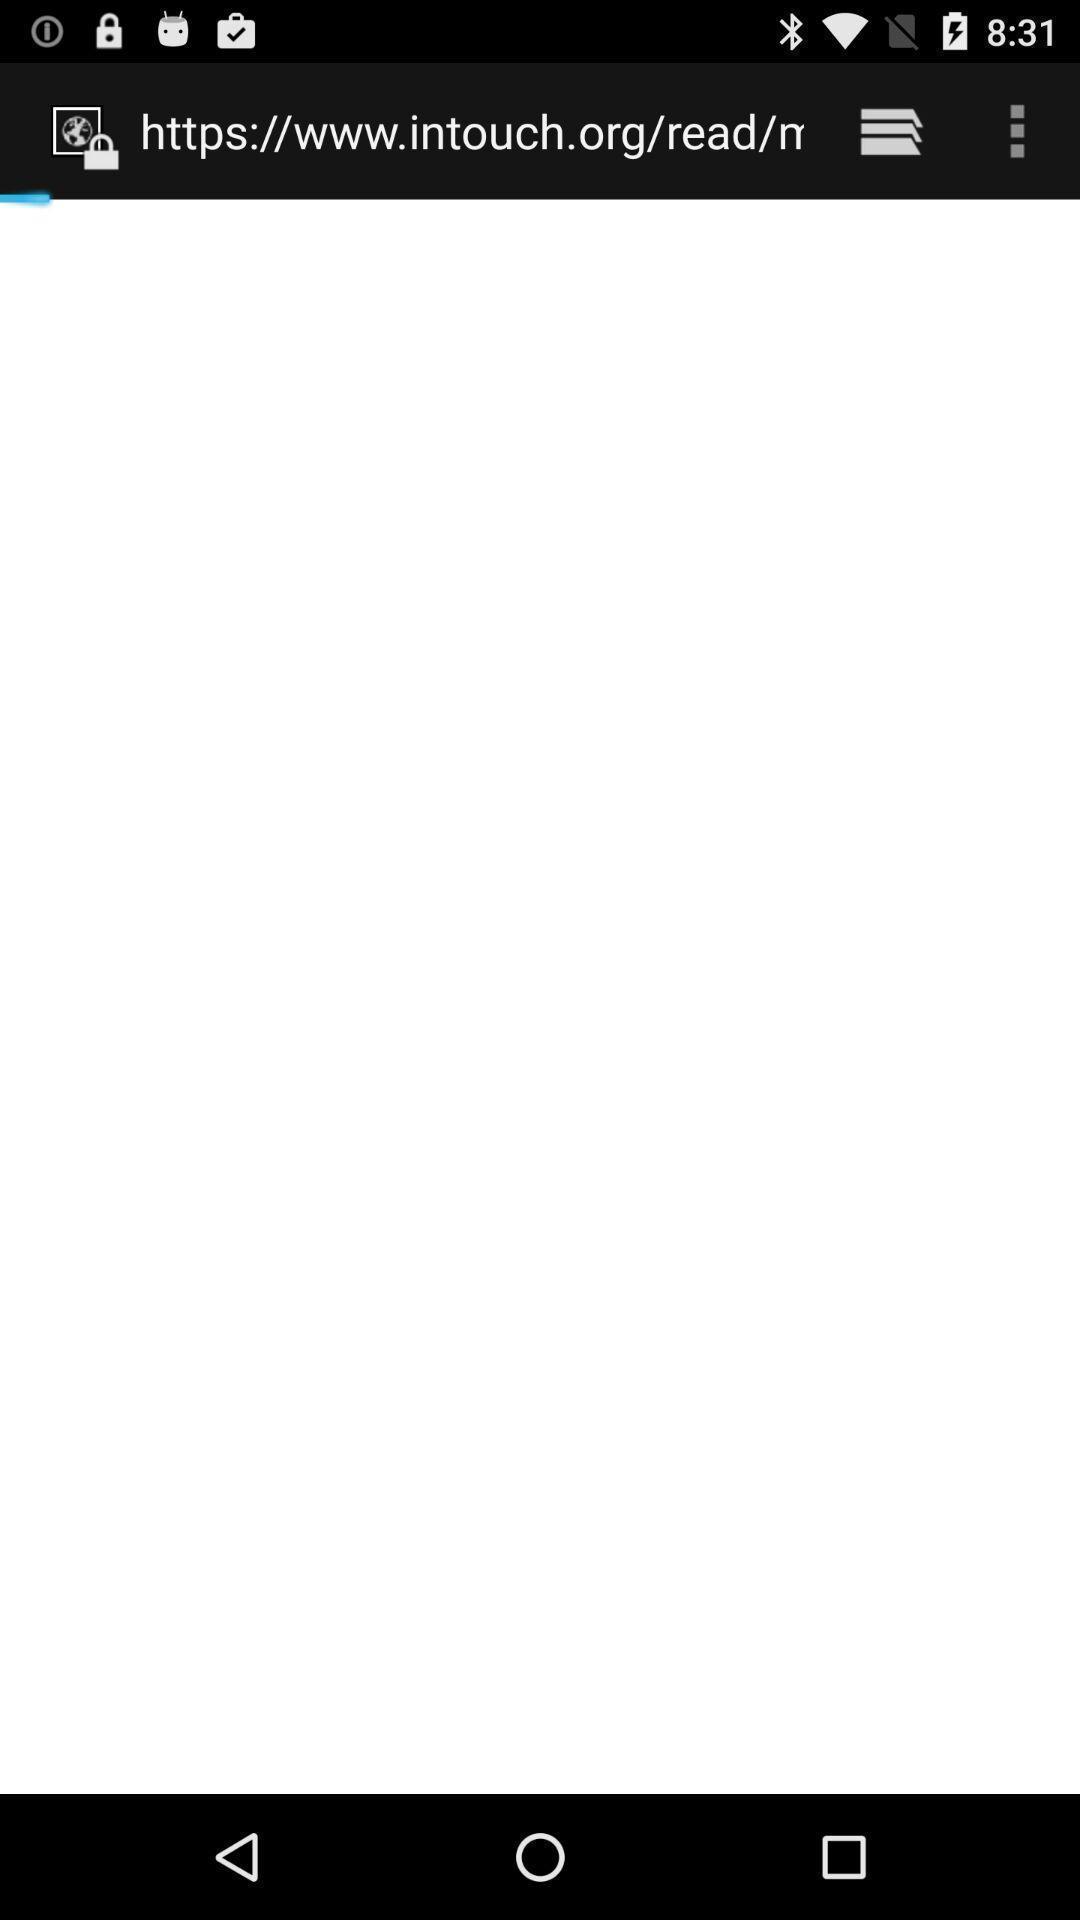Provide a description of this screenshot. Screen shows loading page. 